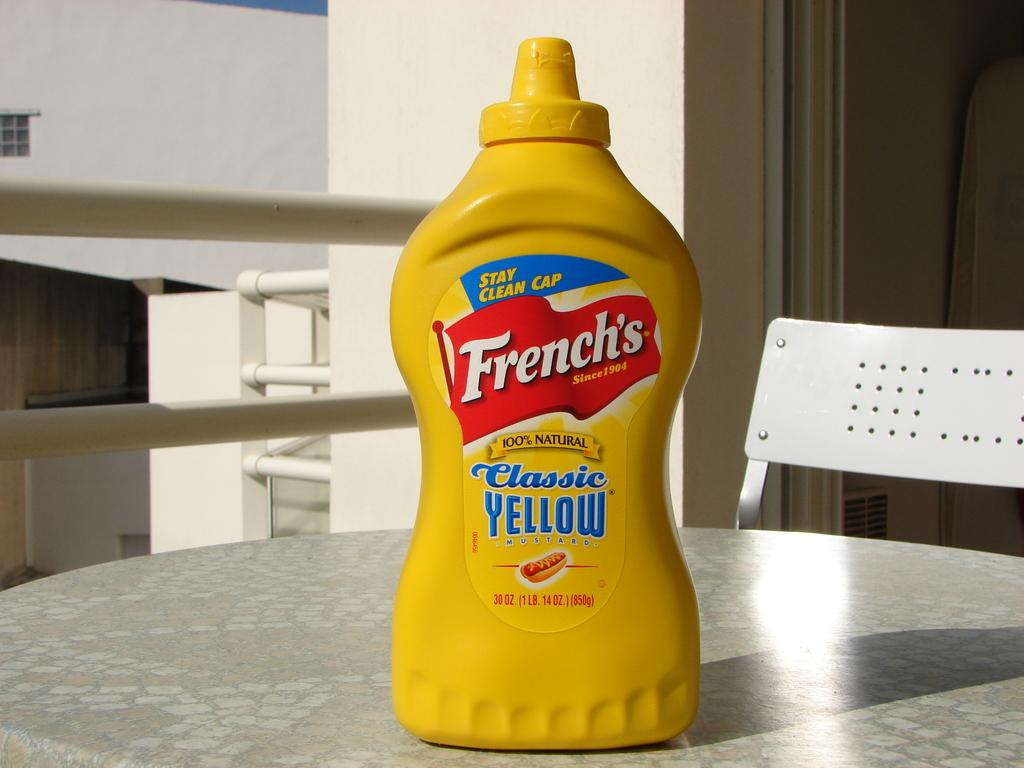<image>
Write a terse but informative summary of the picture. A bottle of French's yellow mustard sits on a table. 